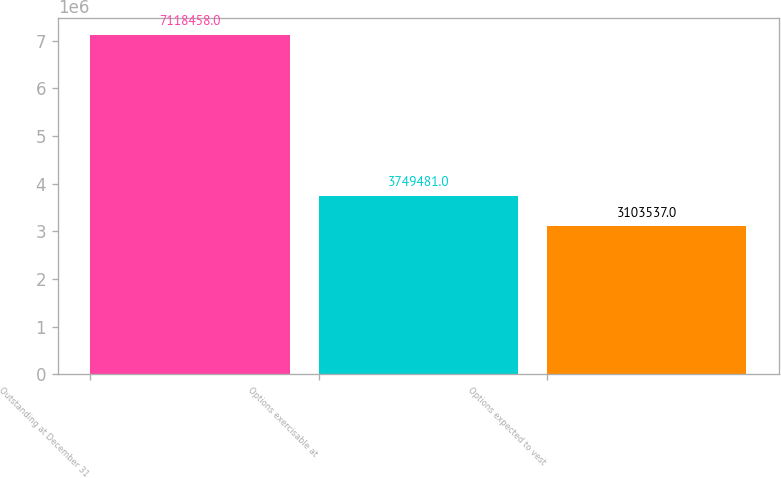Convert chart. <chart><loc_0><loc_0><loc_500><loc_500><bar_chart><fcel>Outstanding at December 31<fcel>Options exercisable at<fcel>Options expected to vest<nl><fcel>7.11846e+06<fcel>3.74948e+06<fcel>3.10354e+06<nl></chart> 